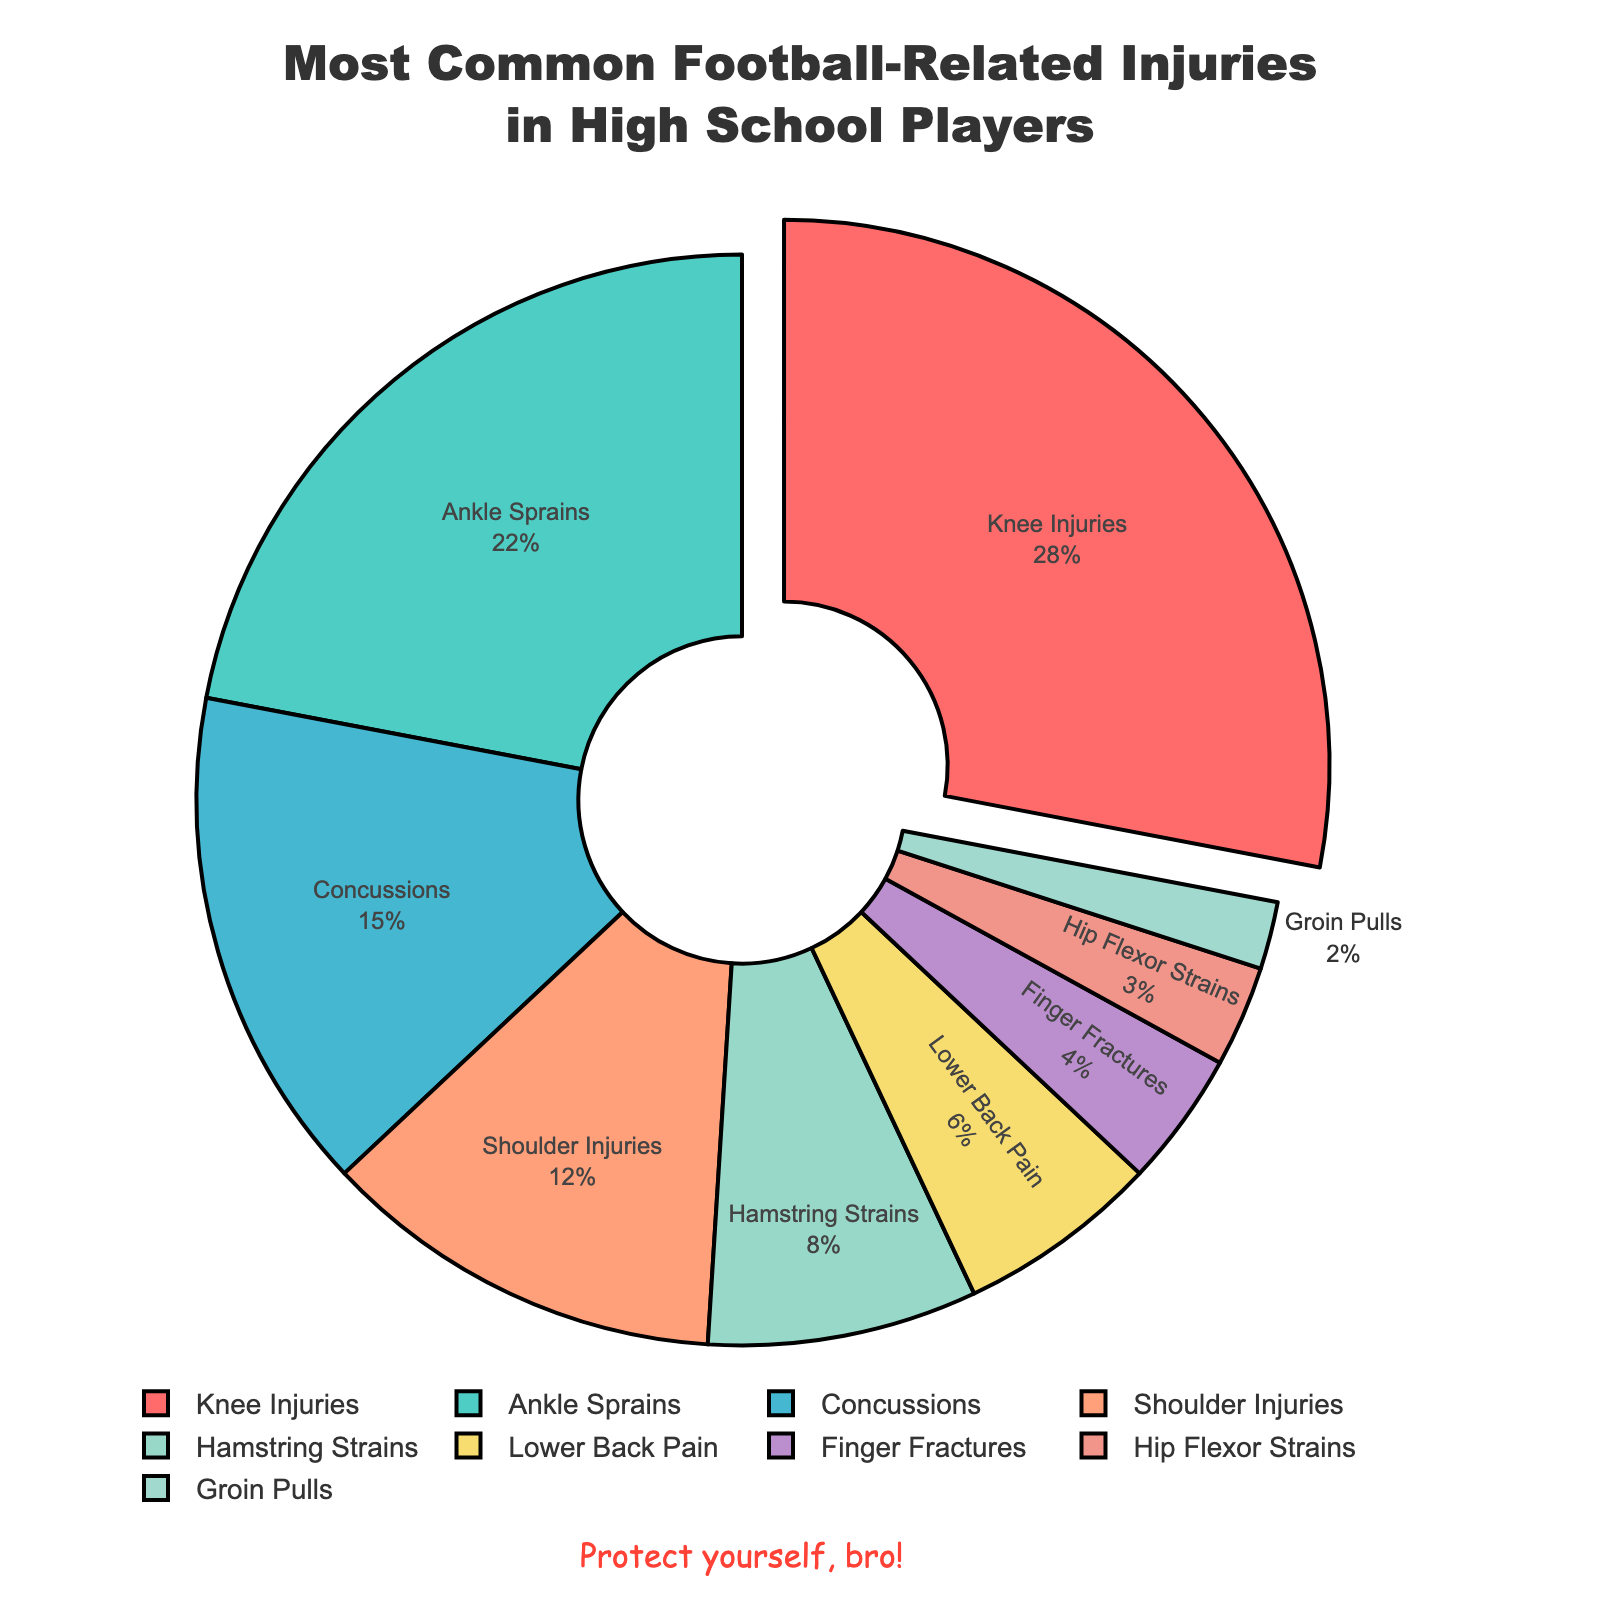what's the largest percentage in the pie chart? The largest percentage in the pie chart is represented by the segment that has the biggest portion relative to the other sections. The "Knee Injuries" section appears to have the largest portion with 28%.
Answer: 28% which injury type has a larger percentage, "Ankle Sprains" or "Concussions"? Comparing the percentages of "Ankle Sprains" and "Concussions", "Ankle Sprains" has 22% while "Concussions" has 15%. Thus, "Ankle Sprains" has a larger percentage than "Concussions".
Answer: Ankle Sprains how much more common are knee injuries compared to shoulder injuries? To find how much more common knee injuries are compared to shoulder injuries, subtract the percentage of shoulder injuries from the percentage of knee injuries: 28% - 12% = 16%.
Answer: 16% what is the combined percentage for Hamstring Strains, Lower Back Pain, and Finger Fractures? To find the combined percentage, add the percentages of Hamstring Strains, Lower Back Pain, and Finger Fractures: 8% + 6% + 4% = 18%.
Answer: 18% which injury type has the smallest percentage? The smallest percentage in the pie chart is represented by the segment with the least visual area, which is "Groin Pulls" at 2%.
Answer: Groin Pulls how much of the pie chart does Hip Flexor Strains and Groin Pulls together take up? To find their combined percentage, add the percentages of Hip Flexor Strains and Groin Pulls: 3% + 2% = 5%.
Answer: 5% are there more injuries associated with the upper or lower body? To determine this, classify each injury as upper or lower body and sum their percentages:
- Upper body: Shoulder Injuries (12%), Finger Fractures (4%) = 16%
- Lower body: Knee Injuries (28%), Ankle Sprains (22%), Hamstring Strains (8%), Lower Back Pain (6%), Hip Flexor Strains (3%), and Groin Pulls (2%) = 69%
Thus, more injuries are associated with the lower body.
Answer: Lower body how many injury types have a percentage greater than 10%? Count the injury types that have percentages greater than 10%: "Knee Injuries" (28%), "Ankle Sprains" (22%), "Concussions" (15%), "Shoulder Injuries" (12%). There are 4 such injury types.
Answer: 4 what percentage of injuries are not related to the knee or ankle? Subtract the combined percentage of knee and ankle injuries from 100%: 100% - (28% + 22%) = 50%.
Answer: 50% 